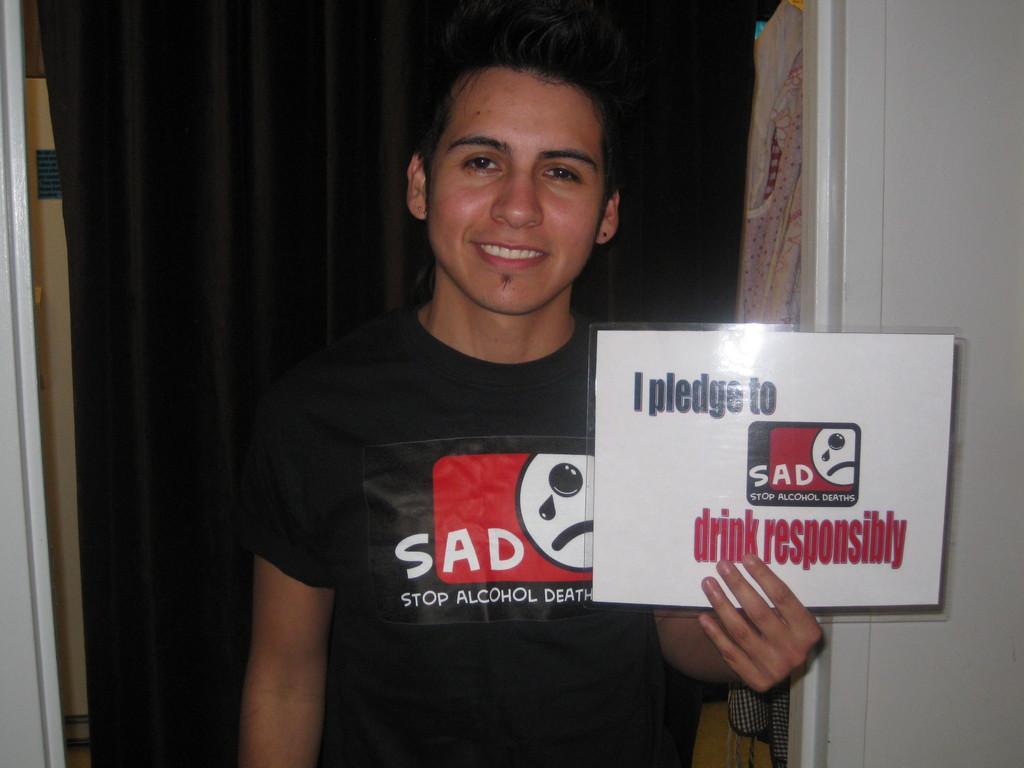Please provide a concise description of this image. In the image in the center we can see one person standing and holding banner. On banner,it is written as "My Pledge To Say Drink Responsibly". And he is smiling,which we can see on his face. In the background there is a wall,cloth,door and few other objects. 